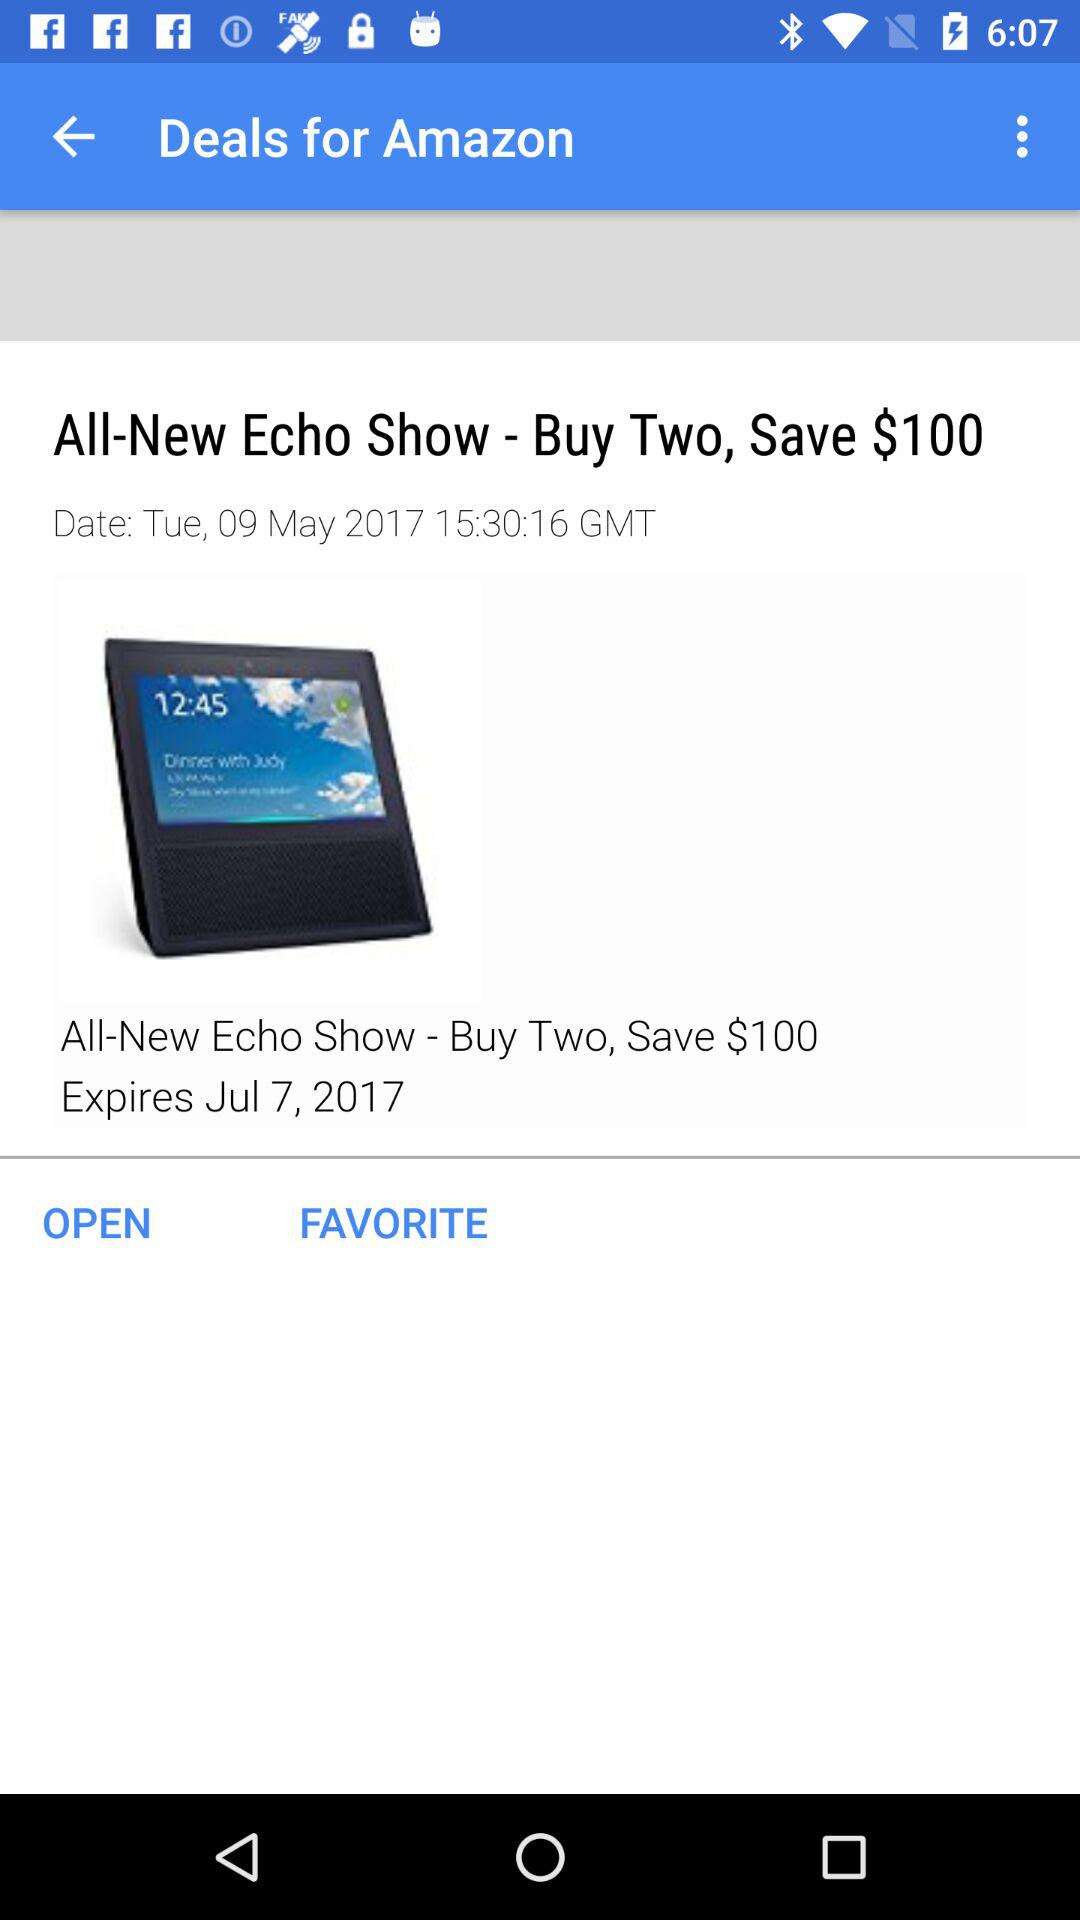What is the mentioned time? The mentioned time is 15:30:16 GMT. 